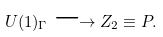<formula> <loc_0><loc_0><loc_500><loc_500>U ( 1 ) _ { \Gamma } \longrightarrow Z _ { 2 } \equiv P .</formula> 